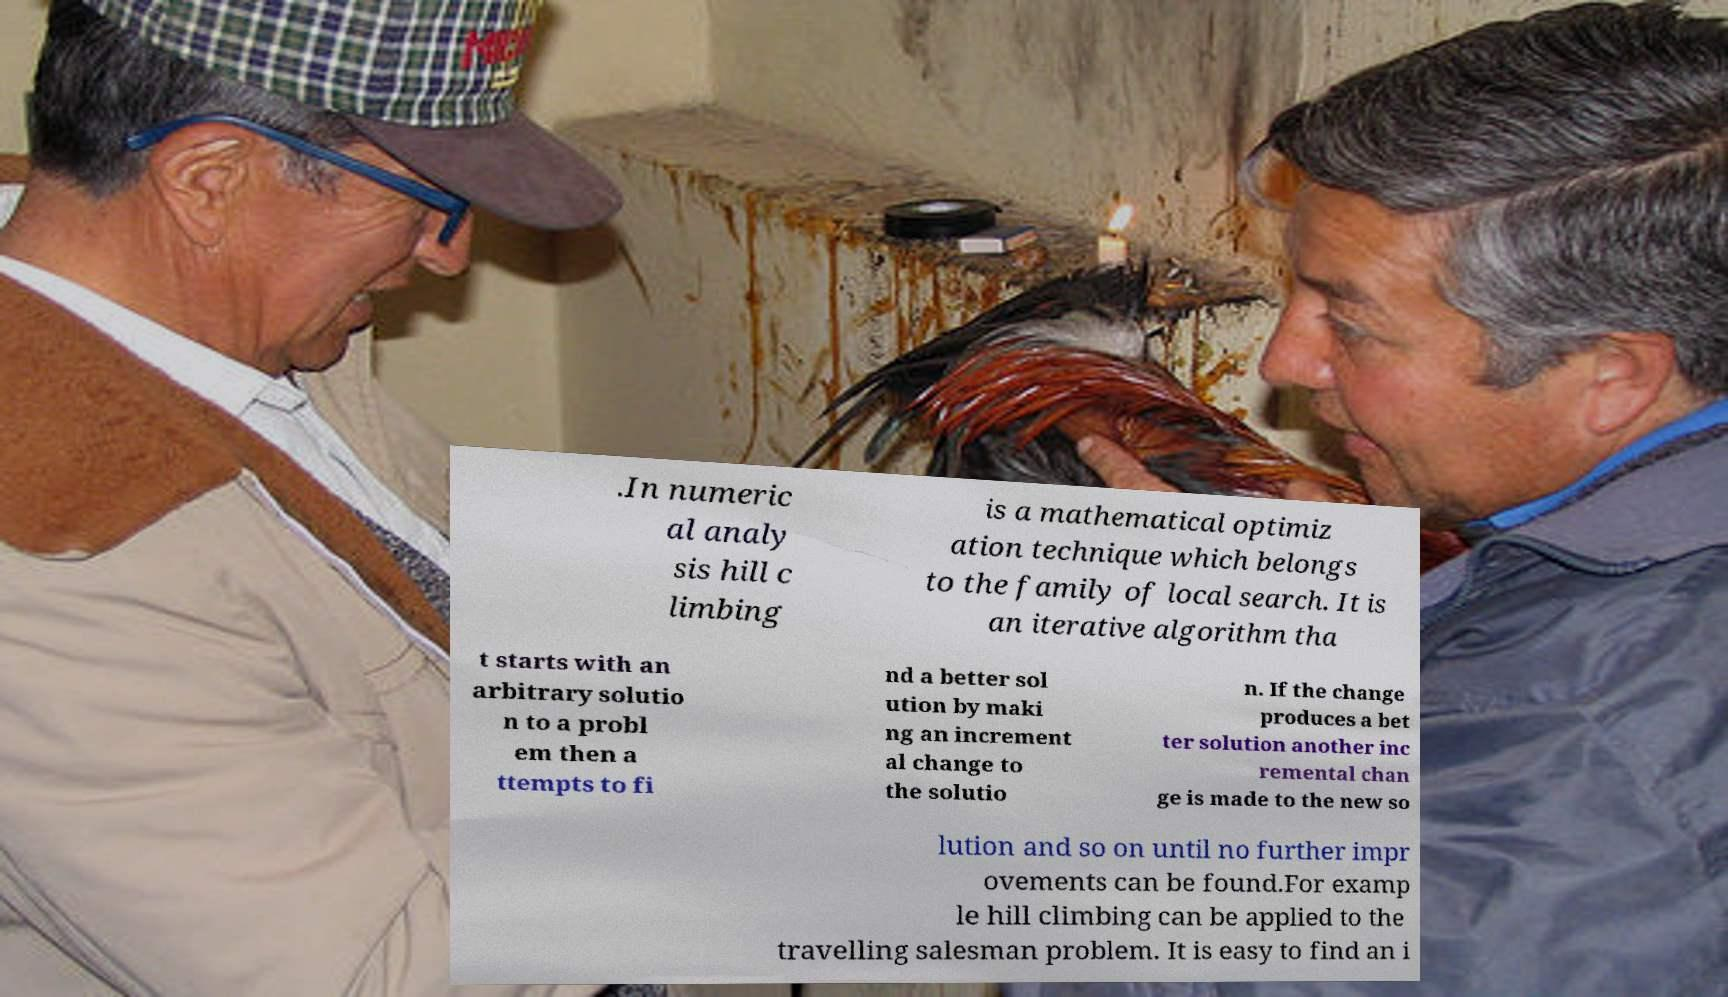What messages or text are displayed in this image? I need them in a readable, typed format. .In numeric al analy sis hill c limbing is a mathematical optimiz ation technique which belongs to the family of local search. It is an iterative algorithm tha t starts with an arbitrary solutio n to a probl em then a ttempts to fi nd a better sol ution by maki ng an increment al change to the solutio n. If the change produces a bet ter solution another inc remental chan ge is made to the new so lution and so on until no further impr ovements can be found.For examp le hill climbing can be applied to the travelling salesman problem. It is easy to find an i 